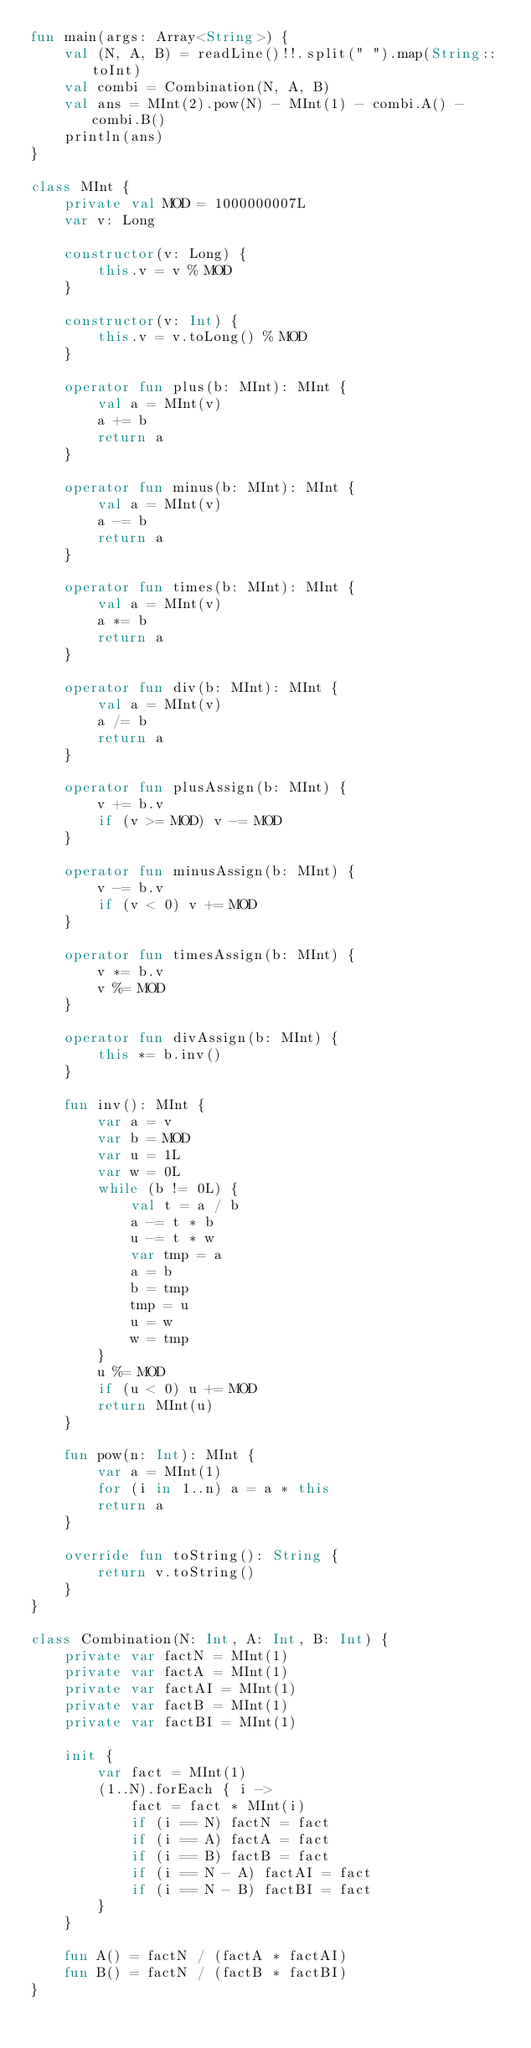<code> <loc_0><loc_0><loc_500><loc_500><_Kotlin_>fun main(args: Array<String>) {
    val (N, A, B) = readLine()!!.split(" ").map(String::toInt)
    val combi = Combination(N, A, B)
    val ans = MInt(2).pow(N) - MInt(1) - combi.A() - combi.B()
    println(ans)
}

class MInt {
    private val MOD = 1000000007L
    var v: Long

    constructor(v: Long) {
        this.v = v % MOD
    }

    constructor(v: Int) {
        this.v = v.toLong() % MOD
    }

    operator fun plus(b: MInt): MInt {
        val a = MInt(v)
        a += b
        return a
    }

    operator fun minus(b: MInt): MInt {
        val a = MInt(v)
        a -= b
        return a
    }

    operator fun times(b: MInt): MInt {
        val a = MInt(v)
        a *= b
        return a
    }

    operator fun div(b: MInt): MInt {
        val a = MInt(v)
        a /= b
        return a
    }

    operator fun plusAssign(b: MInt) {
        v += b.v
        if (v >= MOD) v -= MOD
    }

    operator fun minusAssign(b: MInt) {
        v -= b.v
        if (v < 0) v += MOD
    }

    operator fun timesAssign(b: MInt) {
        v *= b.v
        v %= MOD
    }

    operator fun divAssign(b: MInt) {
        this *= b.inv()
    }

    fun inv(): MInt {
        var a = v
        var b = MOD
        var u = 1L
        var w = 0L
        while (b != 0L) {
            val t = a / b
            a -= t * b
            u -= t * w
            var tmp = a
            a = b
            b = tmp
            tmp = u
            u = w
            w = tmp
        }
        u %= MOD
        if (u < 0) u += MOD
        return MInt(u)
    }

    fun pow(n: Int): MInt {
        var a = MInt(1)
        for (i in 1..n) a = a * this
        return a
    }

    override fun toString(): String {
        return v.toString()
    }
}

class Combination(N: Int, A: Int, B: Int) {
    private var factN = MInt(1)
    private var factA = MInt(1)
    private var factAI = MInt(1)
    private var factB = MInt(1)
    private var factBI = MInt(1)

    init {
        var fact = MInt(1)
        (1..N).forEach { i ->
            fact = fact * MInt(i)
            if (i == N) factN = fact
            if (i == A) factA = fact
            if (i == B) factB = fact
            if (i == N - A) factAI = fact
            if (i == N - B) factBI = fact
        }
    }

    fun A() = factN / (factA * factAI)
    fun B() = factN / (factB * factBI)
}</code> 